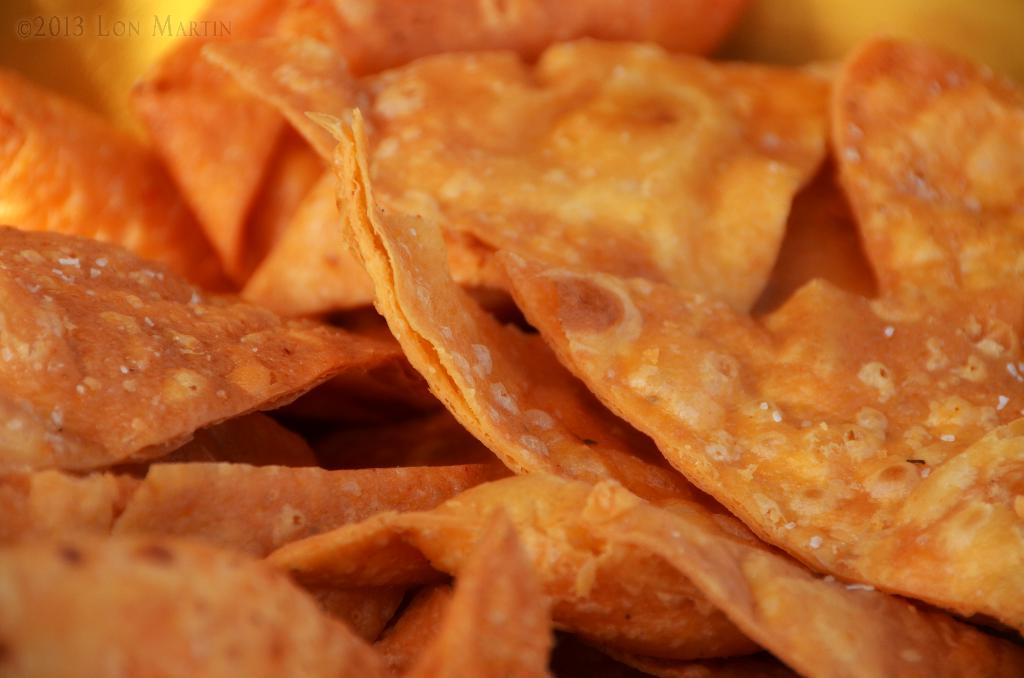What can be seen in the image? There is a food item in the image. Where is the text located in the image? The text is on the top left of the image. How many family members are present in the image? There is no information about family members in the image, as it only contains a food item and text. What type of table is visible in the image? There is no table present in the image; it only contains a food item and text. 